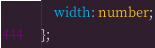Convert code to text. <code><loc_0><loc_0><loc_500><loc_500><_TypeScript_>    width: number;
};
</code> 